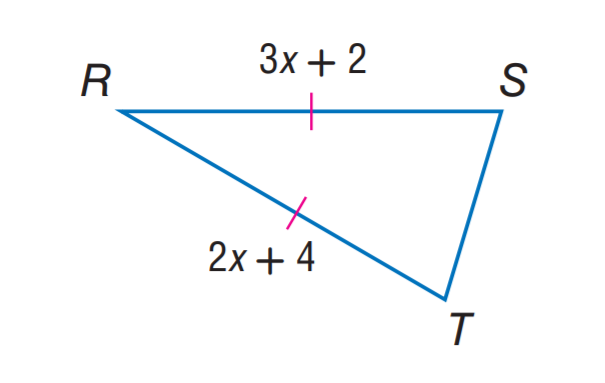Answer the mathemtical geometry problem and directly provide the correct option letter.
Question: Find x.
Choices: A: 2 B: 3 C: 4 D: 8 A 